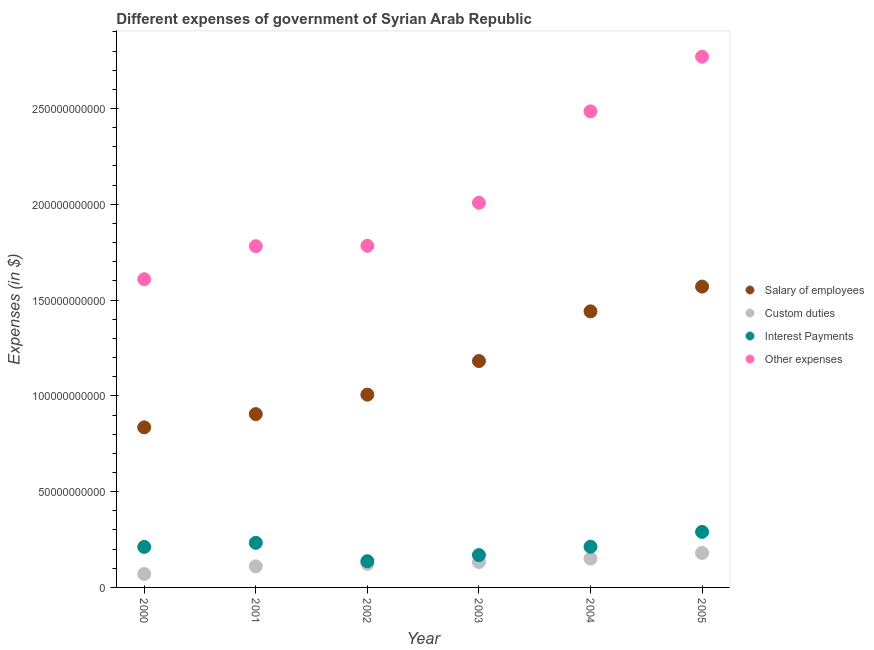Is the number of dotlines equal to the number of legend labels?
Ensure brevity in your answer.  Yes. What is the amount spent on salary of employees in 2004?
Give a very brief answer. 1.44e+11. Across all years, what is the maximum amount spent on custom duties?
Your response must be concise. 1.80e+1. Across all years, what is the minimum amount spent on other expenses?
Provide a short and direct response. 1.61e+11. What is the total amount spent on other expenses in the graph?
Ensure brevity in your answer.  1.24e+12. What is the difference between the amount spent on interest payments in 2001 and that in 2002?
Provide a short and direct response. 9.58e+09. What is the difference between the amount spent on interest payments in 2003 and the amount spent on salary of employees in 2000?
Make the answer very short. -6.67e+1. What is the average amount spent on other expenses per year?
Your response must be concise. 2.07e+11. In the year 2004, what is the difference between the amount spent on interest payments and amount spent on other expenses?
Provide a short and direct response. -2.27e+11. What is the ratio of the amount spent on custom duties in 2003 to that in 2004?
Provide a succinct answer. 0.88. What is the difference between the highest and the second highest amount spent on interest payments?
Your answer should be very brief. 5.72e+09. What is the difference between the highest and the lowest amount spent on other expenses?
Your response must be concise. 1.16e+11. In how many years, is the amount spent on interest payments greater than the average amount spent on interest payments taken over all years?
Offer a terse response. 4. Is the sum of the amount spent on other expenses in 2003 and 2005 greater than the maximum amount spent on salary of employees across all years?
Your answer should be very brief. Yes. Is it the case that in every year, the sum of the amount spent on custom duties and amount spent on other expenses is greater than the sum of amount spent on salary of employees and amount spent on interest payments?
Provide a short and direct response. Yes. Is it the case that in every year, the sum of the amount spent on salary of employees and amount spent on custom duties is greater than the amount spent on interest payments?
Your answer should be very brief. Yes. Does the amount spent on custom duties monotonically increase over the years?
Offer a very short reply. Yes. What is the difference between two consecutive major ticks on the Y-axis?
Keep it short and to the point. 5.00e+1. Are the values on the major ticks of Y-axis written in scientific E-notation?
Ensure brevity in your answer.  No. Does the graph contain any zero values?
Give a very brief answer. No. Where does the legend appear in the graph?
Make the answer very short. Center right. How many legend labels are there?
Your answer should be very brief. 4. How are the legend labels stacked?
Ensure brevity in your answer.  Vertical. What is the title of the graph?
Offer a terse response. Different expenses of government of Syrian Arab Republic. What is the label or title of the Y-axis?
Make the answer very short. Expenses (in $). What is the Expenses (in $) in Salary of employees in 2000?
Ensure brevity in your answer.  8.36e+1. What is the Expenses (in $) of Custom duties in 2000?
Keep it short and to the point. 7.03e+09. What is the Expenses (in $) in Interest Payments in 2000?
Provide a succinct answer. 2.11e+1. What is the Expenses (in $) in Other expenses in 2000?
Offer a terse response. 1.61e+11. What is the Expenses (in $) of Salary of employees in 2001?
Offer a very short reply. 9.05e+1. What is the Expenses (in $) of Custom duties in 2001?
Provide a succinct answer. 1.10e+1. What is the Expenses (in $) of Interest Payments in 2001?
Keep it short and to the point. 2.33e+1. What is the Expenses (in $) in Other expenses in 2001?
Offer a very short reply. 1.78e+11. What is the Expenses (in $) in Salary of employees in 2002?
Give a very brief answer. 1.01e+11. What is the Expenses (in $) of Custom duties in 2002?
Ensure brevity in your answer.  1.23e+1. What is the Expenses (in $) of Interest Payments in 2002?
Offer a very short reply. 1.37e+1. What is the Expenses (in $) of Other expenses in 2002?
Provide a succinct answer. 1.78e+11. What is the Expenses (in $) of Salary of employees in 2003?
Give a very brief answer. 1.18e+11. What is the Expenses (in $) of Custom duties in 2003?
Give a very brief answer. 1.32e+1. What is the Expenses (in $) in Interest Payments in 2003?
Give a very brief answer. 1.69e+1. What is the Expenses (in $) in Other expenses in 2003?
Your answer should be compact. 2.01e+11. What is the Expenses (in $) of Salary of employees in 2004?
Your answer should be compact. 1.44e+11. What is the Expenses (in $) of Custom duties in 2004?
Keep it short and to the point. 1.51e+1. What is the Expenses (in $) of Interest Payments in 2004?
Your response must be concise. 2.12e+1. What is the Expenses (in $) in Other expenses in 2004?
Keep it short and to the point. 2.48e+11. What is the Expenses (in $) in Salary of employees in 2005?
Give a very brief answer. 1.57e+11. What is the Expenses (in $) in Custom duties in 2005?
Your answer should be very brief. 1.80e+1. What is the Expenses (in $) in Interest Payments in 2005?
Your answer should be compact. 2.90e+1. What is the Expenses (in $) in Other expenses in 2005?
Keep it short and to the point. 2.77e+11. Across all years, what is the maximum Expenses (in $) of Salary of employees?
Provide a short and direct response. 1.57e+11. Across all years, what is the maximum Expenses (in $) in Custom duties?
Offer a terse response. 1.80e+1. Across all years, what is the maximum Expenses (in $) of Interest Payments?
Your answer should be compact. 2.90e+1. Across all years, what is the maximum Expenses (in $) of Other expenses?
Offer a very short reply. 2.77e+11. Across all years, what is the minimum Expenses (in $) of Salary of employees?
Ensure brevity in your answer.  8.36e+1. Across all years, what is the minimum Expenses (in $) in Custom duties?
Give a very brief answer. 7.03e+09. Across all years, what is the minimum Expenses (in $) of Interest Payments?
Offer a very short reply. 1.37e+1. Across all years, what is the minimum Expenses (in $) in Other expenses?
Give a very brief answer. 1.61e+11. What is the total Expenses (in $) of Salary of employees in the graph?
Ensure brevity in your answer.  6.94e+11. What is the total Expenses (in $) of Custom duties in the graph?
Offer a terse response. 7.66e+1. What is the total Expenses (in $) in Interest Payments in the graph?
Your answer should be compact. 1.25e+11. What is the total Expenses (in $) in Other expenses in the graph?
Offer a terse response. 1.24e+12. What is the difference between the Expenses (in $) of Salary of employees in 2000 and that in 2001?
Provide a succinct answer. -6.92e+09. What is the difference between the Expenses (in $) of Custom duties in 2000 and that in 2001?
Offer a very short reply. -3.97e+09. What is the difference between the Expenses (in $) in Interest Payments in 2000 and that in 2001?
Ensure brevity in your answer.  -2.14e+09. What is the difference between the Expenses (in $) in Other expenses in 2000 and that in 2001?
Your answer should be very brief. -1.72e+1. What is the difference between the Expenses (in $) in Salary of employees in 2000 and that in 2002?
Your response must be concise. -1.71e+1. What is the difference between the Expenses (in $) of Custom duties in 2000 and that in 2002?
Provide a short and direct response. -5.29e+09. What is the difference between the Expenses (in $) of Interest Payments in 2000 and that in 2002?
Ensure brevity in your answer.  7.45e+09. What is the difference between the Expenses (in $) in Other expenses in 2000 and that in 2002?
Provide a short and direct response. -1.74e+1. What is the difference between the Expenses (in $) of Salary of employees in 2000 and that in 2003?
Make the answer very short. -3.46e+1. What is the difference between the Expenses (in $) in Custom duties in 2000 and that in 2003?
Your answer should be compact. -6.22e+09. What is the difference between the Expenses (in $) of Interest Payments in 2000 and that in 2003?
Keep it short and to the point. 4.27e+09. What is the difference between the Expenses (in $) of Other expenses in 2000 and that in 2003?
Keep it short and to the point. -3.99e+1. What is the difference between the Expenses (in $) in Salary of employees in 2000 and that in 2004?
Your answer should be compact. -6.06e+1. What is the difference between the Expenses (in $) of Custom duties in 2000 and that in 2004?
Your answer should be very brief. -8.04e+09. What is the difference between the Expenses (in $) of Interest Payments in 2000 and that in 2004?
Ensure brevity in your answer.  -1.04e+08. What is the difference between the Expenses (in $) of Other expenses in 2000 and that in 2004?
Provide a succinct answer. -8.76e+1. What is the difference between the Expenses (in $) of Salary of employees in 2000 and that in 2005?
Your answer should be compact. -7.35e+1. What is the difference between the Expenses (in $) of Custom duties in 2000 and that in 2005?
Provide a short and direct response. -1.10e+1. What is the difference between the Expenses (in $) in Interest Payments in 2000 and that in 2005?
Your answer should be compact. -7.85e+09. What is the difference between the Expenses (in $) of Other expenses in 2000 and that in 2005?
Make the answer very short. -1.16e+11. What is the difference between the Expenses (in $) of Salary of employees in 2001 and that in 2002?
Your response must be concise. -1.02e+1. What is the difference between the Expenses (in $) in Custom duties in 2001 and that in 2002?
Your answer should be very brief. -1.32e+09. What is the difference between the Expenses (in $) in Interest Payments in 2001 and that in 2002?
Give a very brief answer. 9.58e+09. What is the difference between the Expenses (in $) of Other expenses in 2001 and that in 2002?
Keep it short and to the point. -2.10e+08. What is the difference between the Expenses (in $) of Salary of employees in 2001 and that in 2003?
Your answer should be very brief. -2.77e+1. What is the difference between the Expenses (in $) of Custom duties in 2001 and that in 2003?
Offer a very short reply. -2.25e+09. What is the difference between the Expenses (in $) of Interest Payments in 2001 and that in 2003?
Provide a succinct answer. 6.40e+09. What is the difference between the Expenses (in $) of Other expenses in 2001 and that in 2003?
Give a very brief answer. -2.27e+1. What is the difference between the Expenses (in $) in Salary of employees in 2001 and that in 2004?
Make the answer very short. -5.36e+1. What is the difference between the Expenses (in $) in Custom duties in 2001 and that in 2004?
Make the answer very short. -4.06e+09. What is the difference between the Expenses (in $) in Interest Payments in 2001 and that in 2004?
Give a very brief answer. 2.03e+09. What is the difference between the Expenses (in $) in Other expenses in 2001 and that in 2004?
Your answer should be compact. -7.04e+1. What is the difference between the Expenses (in $) of Salary of employees in 2001 and that in 2005?
Keep it short and to the point. -6.66e+1. What is the difference between the Expenses (in $) of Custom duties in 2001 and that in 2005?
Ensure brevity in your answer.  -7.00e+09. What is the difference between the Expenses (in $) of Interest Payments in 2001 and that in 2005?
Your answer should be very brief. -5.72e+09. What is the difference between the Expenses (in $) of Other expenses in 2001 and that in 2005?
Your answer should be very brief. -9.89e+1. What is the difference between the Expenses (in $) in Salary of employees in 2002 and that in 2003?
Your answer should be compact. -1.75e+1. What is the difference between the Expenses (in $) of Custom duties in 2002 and that in 2003?
Keep it short and to the point. -9.30e+08. What is the difference between the Expenses (in $) in Interest Payments in 2002 and that in 2003?
Keep it short and to the point. -3.18e+09. What is the difference between the Expenses (in $) of Other expenses in 2002 and that in 2003?
Provide a short and direct response. -2.24e+1. What is the difference between the Expenses (in $) of Salary of employees in 2002 and that in 2004?
Provide a short and direct response. -4.35e+1. What is the difference between the Expenses (in $) of Custom duties in 2002 and that in 2004?
Make the answer very short. -2.75e+09. What is the difference between the Expenses (in $) in Interest Payments in 2002 and that in 2004?
Ensure brevity in your answer.  -7.55e+09. What is the difference between the Expenses (in $) of Other expenses in 2002 and that in 2004?
Provide a succinct answer. -7.02e+1. What is the difference between the Expenses (in $) of Salary of employees in 2002 and that in 2005?
Provide a succinct answer. -5.64e+1. What is the difference between the Expenses (in $) in Custom duties in 2002 and that in 2005?
Offer a very short reply. -5.68e+09. What is the difference between the Expenses (in $) of Interest Payments in 2002 and that in 2005?
Your answer should be very brief. -1.53e+1. What is the difference between the Expenses (in $) of Other expenses in 2002 and that in 2005?
Ensure brevity in your answer.  -9.87e+1. What is the difference between the Expenses (in $) in Salary of employees in 2003 and that in 2004?
Your response must be concise. -2.60e+1. What is the difference between the Expenses (in $) of Custom duties in 2003 and that in 2004?
Your answer should be compact. -1.82e+09. What is the difference between the Expenses (in $) in Interest Payments in 2003 and that in 2004?
Provide a short and direct response. -4.37e+09. What is the difference between the Expenses (in $) of Other expenses in 2003 and that in 2004?
Offer a very short reply. -4.77e+1. What is the difference between the Expenses (in $) of Salary of employees in 2003 and that in 2005?
Give a very brief answer. -3.89e+1. What is the difference between the Expenses (in $) in Custom duties in 2003 and that in 2005?
Give a very brief answer. -4.75e+09. What is the difference between the Expenses (in $) in Interest Payments in 2003 and that in 2005?
Ensure brevity in your answer.  -1.21e+1. What is the difference between the Expenses (in $) of Other expenses in 2003 and that in 2005?
Keep it short and to the point. -7.63e+1. What is the difference between the Expenses (in $) in Salary of employees in 2004 and that in 2005?
Ensure brevity in your answer.  -1.29e+1. What is the difference between the Expenses (in $) of Custom duties in 2004 and that in 2005?
Ensure brevity in your answer.  -2.93e+09. What is the difference between the Expenses (in $) in Interest Payments in 2004 and that in 2005?
Provide a short and direct response. -7.75e+09. What is the difference between the Expenses (in $) of Other expenses in 2004 and that in 2005?
Ensure brevity in your answer.  -2.85e+1. What is the difference between the Expenses (in $) in Salary of employees in 2000 and the Expenses (in $) in Custom duties in 2001?
Make the answer very short. 7.26e+1. What is the difference between the Expenses (in $) of Salary of employees in 2000 and the Expenses (in $) of Interest Payments in 2001?
Ensure brevity in your answer.  6.03e+1. What is the difference between the Expenses (in $) of Salary of employees in 2000 and the Expenses (in $) of Other expenses in 2001?
Ensure brevity in your answer.  -9.46e+1. What is the difference between the Expenses (in $) of Custom duties in 2000 and the Expenses (in $) of Interest Payments in 2001?
Your answer should be very brief. -1.63e+1. What is the difference between the Expenses (in $) in Custom duties in 2000 and the Expenses (in $) in Other expenses in 2001?
Ensure brevity in your answer.  -1.71e+11. What is the difference between the Expenses (in $) in Interest Payments in 2000 and the Expenses (in $) in Other expenses in 2001?
Give a very brief answer. -1.57e+11. What is the difference between the Expenses (in $) in Salary of employees in 2000 and the Expenses (in $) in Custom duties in 2002?
Provide a succinct answer. 7.12e+1. What is the difference between the Expenses (in $) of Salary of employees in 2000 and the Expenses (in $) of Interest Payments in 2002?
Your response must be concise. 6.99e+1. What is the difference between the Expenses (in $) in Salary of employees in 2000 and the Expenses (in $) in Other expenses in 2002?
Make the answer very short. -9.48e+1. What is the difference between the Expenses (in $) in Custom duties in 2000 and the Expenses (in $) in Interest Payments in 2002?
Keep it short and to the point. -6.67e+09. What is the difference between the Expenses (in $) of Custom duties in 2000 and the Expenses (in $) of Other expenses in 2002?
Provide a short and direct response. -1.71e+11. What is the difference between the Expenses (in $) in Interest Payments in 2000 and the Expenses (in $) in Other expenses in 2002?
Your response must be concise. -1.57e+11. What is the difference between the Expenses (in $) of Salary of employees in 2000 and the Expenses (in $) of Custom duties in 2003?
Give a very brief answer. 7.03e+1. What is the difference between the Expenses (in $) of Salary of employees in 2000 and the Expenses (in $) of Interest Payments in 2003?
Make the answer very short. 6.67e+1. What is the difference between the Expenses (in $) in Salary of employees in 2000 and the Expenses (in $) in Other expenses in 2003?
Your answer should be compact. -1.17e+11. What is the difference between the Expenses (in $) of Custom duties in 2000 and the Expenses (in $) of Interest Payments in 2003?
Your response must be concise. -9.85e+09. What is the difference between the Expenses (in $) of Custom duties in 2000 and the Expenses (in $) of Other expenses in 2003?
Offer a terse response. -1.94e+11. What is the difference between the Expenses (in $) of Interest Payments in 2000 and the Expenses (in $) of Other expenses in 2003?
Your answer should be compact. -1.80e+11. What is the difference between the Expenses (in $) of Salary of employees in 2000 and the Expenses (in $) of Custom duties in 2004?
Make the answer very short. 6.85e+1. What is the difference between the Expenses (in $) of Salary of employees in 2000 and the Expenses (in $) of Interest Payments in 2004?
Make the answer very short. 6.23e+1. What is the difference between the Expenses (in $) in Salary of employees in 2000 and the Expenses (in $) in Other expenses in 2004?
Provide a short and direct response. -1.65e+11. What is the difference between the Expenses (in $) in Custom duties in 2000 and the Expenses (in $) in Interest Payments in 2004?
Your response must be concise. -1.42e+1. What is the difference between the Expenses (in $) of Custom duties in 2000 and the Expenses (in $) of Other expenses in 2004?
Offer a terse response. -2.41e+11. What is the difference between the Expenses (in $) of Interest Payments in 2000 and the Expenses (in $) of Other expenses in 2004?
Keep it short and to the point. -2.27e+11. What is the difference between the Expenses (in $) of Salary of employees in 2000 and the Expenses (in $) of Custom duties in 2005?
Make the answer very short. 6.56e+1. What is the difference between the Expenses (in $) in Salary of employees in 2000 and the Expenses (in $) in Interest Payments in 2005?
Ensure brevity in your answer.  5.46e+1. What is the difference between the Expenses (in $) in Salary of employees in 2000 and the Expenses (in $) in Other expenses in 2005?
Offer a terse response. -1.93e+11. What is the difference between the Expenses (in $) of Custom duties in 2000 and the Expenses (in $) of Interest Payments in 2005?
Give a very brief answer. -2.20e+1. What is the difference between the Expenses (in $) in Custom duties in 2000 and the Expenses (in $) in Other expenses in 2005?
Your answer should be very brief. -2.70e+11. What is the difference between the Expenses (in $) in Interest Payments in 2000 and the Expenses (in $) in Other expenses in 2005?
Provide a succinct answer. -2.56e+11. What is the difference between the Expenses (in $) of Salary of employees in 2001 and the Expenses (in $) of Custom duties in 2002?
Offer a terse response. 7.82e+1. What is the difference between the Expenses (in $) of Salary of employees in 2001 and the Expenses (in $) of Interest Payments in 2002?
Make the answer very short. 7.68e+1. What is the difference between the Expenses (in $) in Salary of employees in 2001 and the Expenses (in $) in Other expenses in 2002?
Ensure brevity in your answer.  -8.79e+1. What is the difference between the Expenses (in $) of Custom duties in 2001 and the Expenses (in $) of Interest Payments in 2002?
Offer a very short reply. -2.70e+09. What is the difference between the Expenses (in $) in Custom duties in 2001 and the Expenses (in $) in Other expenses in 2002?
Your answer should be very brief. -1.67e+11. What is the difference between the Expenses (in $) in Interest Payments in 2001 and the Expenses (in $) in Other expenses in 2002?
Provide a short and direct response. -1.55e+11. What is the difference between the Expenses (in $) in Salary of employees in 2001 and the Expenses (in $) in Custom duties in 2003?
Provide a short and direct response. 7.72e+1. What is the difference between the Expenses (in $) in Salary of employees in 2001 and the Expenses (in $) in Interest Payments in 2003?
Give a very brief answer. 7.36e+1. What is the difference between the Expenses (in $) of Salary of employees in 2001 and the Expenses (in $) of Other expenses in 2003?
Your response must be concise. -1.10e+11. What is the difference between the Expenses (in $) in Custom duties in 2001 and the Expenses (in $) in Interest Payments in 2003?
Your response must be concise. -5.88e+09. What is the difference between the Expenses (in $) of Custom duties in 2001 and the Expenses (in $) of Other expenses in 2003?
Your answer should be compact. -1.90e+11. What is the difference between the Expenses (in $) in Interest Payments in 2001 and the Expenses (in $) in Other expenses in 2003?
Provide a short and direct response. -1.77e+11. What is the difference between the Expenses (in $) of Salary of employees in 2001 and the Expenses (in $) of Custom duties in 2004?
Keep it short and to the point. 7.54e+1. What is the difference between the Expenses (in $) in Salary of employees in 2001 and the Expenses (in $) in Interest Payments in 2004?
Keep it short and to the point. 6.92e+1. What is the difference between the Expenses (in $) in Salary of employees in 2001 and the Expenses (in $) in Other expenses in 2004?
Offer a very short reply. -1.58e+11. What is the difference between the Expenses (in $) in Custom duties in 2001 and the Expenses (in $) in Interest Payments in 2004?
Make the answer very short. -1.03e+1. What is the difference between the Expenses (in $) of Custom duties in 2001 and the Expenses (in $) of Other expenses in 2004?
Ensure brevity in your answer.  -2.37e+11. What is the difference between the Expenses (in $) in Interest Payments in 2001 and the Expenses (in $) in Other expenses in 2004?
Keep it short and to the point. -2.25e+11. What is the difference between the Expenses (in $) in Salary of employees in 2001 and the Expenses (in $) in Custom duties in 2005?
Make the answer very short. 7.25e+1. What is the difference between the Expenses (in $) of Salary of employees in 2001 and the Expenses (in $) of Interest Payments in 2005?
Ensure brevity in your answer.  6.15e+1. What is the difference between the Expenses (in $) of Salary of employees in 2001 and the Expenses (in $) of Other expenses in 2005?
Your response must be concise. -1.87e+11. What is the difference between the Expenses (in $) in Custom duties in 2001 and the Expenses (in $) in Interest Payments in 2005?
Your response must be concise. -1.80e+1. What is the difference between the Expenses (in $) of Custom duties in 2001 and the Expenses (in $) of Other expenses in 2005?
Ensure brevity in your answer.  -2.66e+11. What is the difference between the Expenses (in $) of Interest Payments in 2001 and the Expenses (in $) of Other expenses in 2005?
Provide a succinct answer. -2.54e+11. What is the difference between the Expenses (in $) of Salary of employees in 2002 and the Expenses (in $) of Custom duties in 2003?
Your answer should be very brief. 8.74e+1. What is the difference between the Expenses (in $) of Salary of employees in 2002 and the Expenses (in $) of Interest Payments in 2003?
Offer a terse response. 8.38e+1. What is the difference between the Expenses (in $) of Salary of employees in 2002 and the Expenses (in $) of Other expenses in 2003?
Your response must be concise. -1.00e+11. What is the difference between the Expenses (in $) in Custom duties in 2002 and the Expenses (in $) in Interest Payments in 2003?
Keep it short and to the point. -4.56e+09. What is the difference between the Expenses (in $) of Custom duties in 2002 and the Expenses (in $) of Other expenses in 2003?
Make the answer very short. -1.88e+11. What is the difference between the Expenses (in $) of Interest Payments in 2002 and the Expenses (in $) of Other expenses in 2003?
Make the answer very short. -1.87e+11. What is the difference between the Expenses (in $) of Salary of employees in 2002 and the Expenses (in $) of Custom duties in 2004?
Ensure brevity in your answer.  8.56e+1. What is the difference between the Expenses (in $) in Salary of employees in 2002 and the Expenses (in $) in Interest Payments in 2004?
Your answer should be very brief. 7.94e+1. What is the difference between the Expenses (in $) of Salary of employees in 2002 and the Expenses (in $) of Other expenses in 2004?
Your answer should be compact. -1.48e+11. What is the difference between the Expenses (in $) of Custom duties in 2002 and the Expenses (in $) of Interest Payments in 2004?
Offer a terse response. -8.93e+09. What is the difference between the Expenses (in $) of Custom duties in 2002 and the Expenses (in $) of Other expenses in 2004?
Your answer should be compact. -2.36e+11. What is the difference between the Expenses (in $) in Interest Payments in 2002 and the Expenses (in $) in Other expenses in 2004?
Keep it short and to the point. -2.35e+11. What is the difference between the Expenses (in $) of Salary of employees in 2002 and the Expenses (in $) of Custom duties in 2005?
Provide a succinct answer. 8.26e+1. What is the difference between the Expenses (in $) of Salary of employees in 2002 and the Expenses (in $) of Interest Payments in 2005?
Your response must be concise. 7.16e+1. What is the difference between the Expenses (in $) of Salary of employees in 2002 and the Expenses (in $) of Other expenses in 2005?
Provide a succinct answer. -1.76e+11. What is the difference between the Expenses (in $) in Custom duties in 2002 and the Expenses (in $) in Interest Payments in 2005?
Your answer should be very brief. -1.67e+1. What is the difference between the Expenses (in $) of Custom duties in 2002 and the Expenses (in $) of Other expenses in 2005?
Your answer should be very brief. -2.65e+11. What is the difference between the Expenses (in $) of Interest Payments in 2002 and the Expenses (in $) of Other expenses in 2005?
Offer a terse response. -2.63e+11. What is the difference between the Expenses (in $) of Salary of employees in 2003 and the Expenses (in $) of Custom duties in 2004?
Keep it short and to the point. 1.03e+11. What is the difference between the Expenses (in $) of Salary of employees in 2003 and the Expenses (in $) of Interest Payments in 2004?
Provide a short and direct response. 9.69e+1. What is the difference between the Expenses (in $) in Salary of employees in 2003 and the Expenses (in $) in Other expenses in 2004?
Give a very brief answer. -1.30e+11. What is the difference between the Expenses (in $) of Custom duties in 2003 and the Expenses (in $) of Interest Payments in 2004?
Ensure brevity in your answer.  -8.00e+09. What is the difference between the Expenses (in $) in Custom duties in 2003 and the Expenses (in $) in Other expenses in 2004?
Ensure brevity in your answer.  -2.35e+11. What is the difference between the Expenses (in $) in Interest Payments in 2003 and the Expenses (in $) in Other expenses in 2004?
Keep it short and to the point. -2.32e+11. What is the difference between the Expenses (in $) in Salary of employees in 2003 and the Expenses (in $) in Custom duties in 2005?
Your answer should be compact. 1.00e+11. What is the difference between the Expenses (in $) in Salary of employees in 2003 and the Expenses (in $) in Interest Payments in 2005?
Your response must be concise. 8.92e+1. What is the difference between the Expenses (in $) of Salary of employees in 2003 and the Expenses (in $) of Other expenses in 2005?
Offer a very short reply. -1.59e+11. What is the difference between the Expenses (in $) of Custom duties in 2003 and the Expenses (in $) of Interest Payments in 2005?
Make the answer very short. -1.58e+1. What is the difference between the Expenses (in $) of Custom duties in 2003 and the Expenses (in $) of Other expenses in 2005?
Make the answer very short. -2.64e+11. What is the difference between the Expenses (in $) in Interest Payments in 2003 and the Expenses (in $) in Other expenses in 2005?
Your response must be concise. -2.60e+11. What is the difference between the Expenses (in $) of Salary of employees in 2004 and the Expenses (in $) of Custom duties in 2005?
Make the answer very short. 1.26e+11. What is the difference between the Expenses (in $) in Salary of employees in 2004 and the Expenses (in $) in Interest Payments in 2005?
Make the answer very short. 1.15e+11. What is the difference between the Expenses (in $) of Salary of employees in 2004 and the Expenses (in $) of Other expenses in 2005?
Offer a very short reply. -1.33e+11. What is the difference between the Expenses (in $) in Custom duties in 2004 and the Expenses (in $) in Interest Payments in 2005?
Ensure brevity in your answer.  -1.39e+1. What is the difference between the Expenses (in $) of Custom duties in 2004 and the Expenses (in $) of Other expenses in 2005?
Your answer should be compact. -2.62e+11. What is the difference between the Expenses (in $) in Interest Payments in 2004 and the Expenses (in $) in Other expenses in 2005?
Keep it short and to the point. -2.56e+11. What is the average Expenses (in $) in Salary of employees per year?
Give a very brief answer. 1.16e+11. What is the average Expenses (in $) in Custom duties per year?
Provide a short and direct response. 1.28e+1. What is the average Expenses (in $) in Interest Payments per year?
Your response must be concise. 2.09e+1. What is the average Expenses (in $) of Other expenses per year?
Ensure brevity in your answer.  2.07e+11. In the year 2000, what is the difference between the Expenses (in $) of Salary of employees and Expenses (in $) of Custom duties?
Your answer should be compact. 7.65e+1. In the year 2000, what is the difference between the Expenses (in $) in Salary of employees and Expenses (in $) in Interest Payments?
Provide a succinct answer. 6.24e+1. In the year 2000, what is the difference between the Expenses (in $) of Salary of employees and Expenses (in $) of Other expenses?
Your answer should be compact. -7.73e+1. In the year 2000, what is the difference between the Expenses (in $) of Custom duties and Expenses (in $) of Interest Payments?
Your answer should be very brief. -1.41e+1. In the year 2000, what is the difference between the Expenses (in $) in Custom duties and Expenses (in $) in Other expenses?
Offer a terse response. -1.54e+11. In the year 2000, what is the difference between the Expenses (in $) of Interest Payments and Expenses (in $) of Other expenses?
Give a very brief answer. -1.40e+11. In the year 2001, what is the difference between the Expenses (in $) of Salary of employees and Expenses (in $) of Custom duties?
Provide a succinct answer. 7.95e+1. In the year 2001, what is the difference between the Expenses (in $) in Salary of employees and Expenses (in $) in Interest Payments?
Keep it short and to the point. 6.72e+1. In the year 2001, what is the difference between the Expenses (in $) of Salary of employees and Expenses (in $) of Other expenses?
Make the answer very short. -8.76e+1. In the year 2001, what is the difference between the Expenses (in $) of Custom duties and Expenses (in $) of Interest Payments?
Your answer should be compact. -1.23e+1. In the year 2001, what is the difference between the Expenses (in $) of Custom duties and Expenses (in $) of Other expenses?
Keep it short and to the point. -1.67e+11. In the year 2001, what is the difference between the Expenses (in $) of Interest Payments and Expenses (in $) of Other expenses?
Offer a very short reply. -1.55e+11. In the year 2002, what is the difference between the Expenses (in $) of Salary of employees and Expenses (in $) of Custom duties?
Keep it short and to the point. 8.83e+1. In the year 2002, what is the difference between the Expenses (in $) of Salary of employees and Expenses (in $) of Interest Payments?
Provide a short and direct response. 8.69e+1. In the year 2002, what is the difference between the Expenses (in $) of Salary of employees and Expenses (in $) of Other expenses?
Your answer should be compact. -7.77e+1. In the year 2002, what is the difference between the Expenses (in $) of Custom duties and Expenses (in $) of Interest Payments?
Your answer should be compact. -1.38e+09. In the year 2002, what is the difference between the Expenses (in $) of Custom duties and Expenses (in $) of Other expenses?
Keep it short and to the point. -1.66e+11. In the year 2002, what is the difference between the Expenses (in $) of Interest Payments and Expenses (in $) of Other expenses?
Ensure brevity in your answer.  -1.65e+11. In the year 2003, what is the difference between the Expenses (in $) of Salary of employees and Expenses (in $) of Custom duties?
Make the answer very short. 1.05e+11. In the year 2003, what is the difference between the Expenses (in $) of Salary of employees and Expenses (in $) of Interest Payments?
Offer a terse response. 1.01e+11. In the year 2003, what is the difference between the Expenses (in $) in Salary of employees and Expenses (in $) in Other expenses?
Give a very brief answer. -8.26e+1. In the year 2003, what is the difference between the Expenses (in $) in Custom duties and Expenses (in $) in Interest Payments?
Provide a short and direct response. -3.63e+09. In the year 2003, what is the difference between the Expenses (in $) in Custom duties and Expenses (in $) in Other expenses?
Provide a succinct answer. -1.88e+11. In the year 2003, what is the difference between the Expenses (in $) of Interest Payments and Expenses (in $) of Other expenses?
Make the answer very short. -1.84e+11. In the year 2004, what is the difference between the Expenses (in $) in Salary of employees and Expenses (in $) in Custom duties?
Make the answer very short. 1.29e+11. In the year 2004, what is the difference between the Expenses (in $) in Salary of employees and Expenses (in $) in Interest Payments?
Offer a very short reply. 1.23e+11. In the year 2004, what is the difference between the Expenses (in $) in Salary of employees and Expenses (in $) in Other expenses?
Offer a very short reply. -1.04e+11. In the year 2004, what is the difference between the Expenses (in $) in Custom duties and Expenses (in $) in Interest Payments?
Keep it short and to the point. -6.19e+09. In the year 2004, what is the difference between the Expenses (in $) in Custom duties and Expenses (in $) in Other expenses?
Your answer should be compact. -2.33e+11. In the year 2004, what is the difference between the Expenses (in $) in Interest Payments and Expenses (in $) in Other expenses?
Offer a terse response. -2.27e+11. In the year 2005, what is the difference between the Expenses (in $) of Salary of employees and Expenses (in $) of Custom duties?
Your answer should be very brief. 1.39e+11. In the year 2005, what is the difference between the Expenses (in $) in Salary of employees and Expenses (in $) in Interest Payments?
Make the answer very short. 1.28e+11. In the year 2005, what is the difference between the Expenses (in $) of Salary of employees and Expenses (in $) of Other expenses?
Ensure brevity in your answer.  -1.20e+11. In the year 2005, what is the difference between the Expenses (in $) in Custom duties and Expenses (in $) in Interest Payments?
Keep it short and to the point. -1.10e+1. In the year 2005, what is the difference between the Expenses (in $) of Custom duties and Expenses (in $) of Other expenses?
Give a very brief answer. -2.59e+11. In the year 2005, what is the difference between the Expenses (in $) of Interest Payments and Expenses (in $) of Other expenses?
Ensure brevity in your answer.  -2.48e+11. What is the ratio of the Expenses (in $) in Salary of employees in 2000 to that in 2001?
Provide a succinct answer. 0.92. What is the ratio of the Expenses (in $) in Custom duties in 2000 to that in 2001?
Give a very brief answer. 0.64. What is the ratio of the Expenses (in $) of Interest Payments in 2000 to that in 2001?
Give a very brief answer. 0.91. What is the ratio of the Expenses (in $) in Other expenses in 2000 to that in 2001?
Provide a short and direct response. 0.9. What is the ratio of the Expenses (in $) of Salary of employees in 2000 to that in 2002?
Your answer should be very brief. 0.83. What is the ratio of the Expenses (in $) in Custom duties in 2000 to that in 2002?
Make the answer very short. 0.57. What is the ratio of the Expenses (in $) in Interest Payments in 2000 to that in 2002?
Your answer should be very brief. 1.54. What is the ratio of the Expenses (in $) in Other expenses in 2000 to that in 2002?
Ensure brevity in your answer.  0.9. What is the ratio of the Expenses (in $) of Salary of employees in 2000 to that in 2003?
Your response must be concise. 0.71. What is the ratio of the Expenses (in $) in Custom duties in 2000 to that in 2003?
Provide a succinct answer. 0.53. What is the ratio of the Expenses (in $) in Interest Payments in 2000 to that in 2003?
Provide a short and direct response. 1.25. What is the ratio of the Expenses (in $) of Other expenses in 2000 to that in 2003?
Provide a succinct answer. 0.8. What is the ratio of the Expenses (in $) of Salary of employees in 2000 to that in 2004?
Ensure brevity in your answer.  0.58. What is the ratio of the Expenses (in $) of Custom duties in 2000 to that in 2004?
Your response must be concise. 0.47. What is the ratio of the Expenses (in $) of Other expenses in 2000 to that in 2004?
Your response must be concise. 0.65. What is the ratio of the Expenses (in $) in Salary of employees in 2000 to that in 2005?
Offer a very short reply. 0.53. What is the ratio of the Expenses (in $) in Custom duties in 2000 to that in 2005?
Make the answer very short. 0.39. What is the ratio of the Expenses (in $) in Interest Payments in 2000 to that in 2005?
Your answer should be very brief. 0.73. What is the ratio of the Expenses (in $) of Other expenses in 2000 to that in 2005?
Keep it short and to the point. 0.58. What is the ratio of the Expenses (in $) of Salary of employees in 2001 to that in 2002?
Give a very brief answer. 0.9. What is the ratio of the Expenses (in $) in Custom duties in 2001 to that in 2002?
Offer a terse response. 0.89. What is the ratio of the Expenses (in $) in Interest Payments in 2001 to that in 2002?
Your response must be concise. 1.7. What is the ratio of the Expenses (in $) in Other expenses in 2001 to that in 2002?
Your answer should be very brief. 1. What is the ratio of the Expenses (in $) of Salary of employees in 2001 to that in 2003?
Ensure brevity in your answer.  0.77. What is the ratio of the Expenses (in $) of Custom duties in 2001 to that in 2003?
Ensure brevity in your answer.  0.83. What is the ratio of the Expenses (in $) in Interest Payments in 2001 to that in 2003?
Your response must be concise. 1.38. What is the ratio of the Expenses (in $) in Other expenses in 2001 to that in 2003?
Provide a short and direct response. 0.89. What is the ratio of the Expenses (in $) in Salary of employees in 2001 to that in 2004?
Give a very brief answer. 0.63. What is the ratio of the Expenses (in $) in Custom duties in 2001 to that in 2004?
Provide a succinct answer. 0.73. What is the ratio of the Expenses (in $) in Interest Payments in 2001 to that in 2004?
Your response must be concise. 1.1. What is the ratio of the Expenses (in $) of Other expenses in 2001 to that in 2004?
Keep it short and to the point. 0.72. What is the ratio of the Expenses (in $) of Salary of employees in 2001 to that in 2005?
Make the answer very short. 0.58. What is the ratio of the Expenses (in $) of Custom duties in 2001 to that in 2005?
Your answer should be very brief. 0.61. What is the ratio of the Expenses (in $) in Interest Payments in 2001 to that in 2005?
Offer a very short reply. 0.8. What is the ratio of the Expenses (in $) of Other expenses in 2001 to that in 2005?
Provide a short and direct response. 0.64. What is the ratio of the Expenses (in $) of Salary of employees in 2002 to that in 2003?
Offer a terse response. 0.85. What is the ratio of the Expenses (in $) of Custom duties in 2002 to that in 2003?
Offer a very short reply. 0.93. What is the ratio of the Expenses (in $) of Interest Payments in 2002 to that in 2003?
Give a very brief answer. 0.81. What is the ratio of the Expenses (in $) in Other expenses in 2002 to that in 2003?
Give a very brief answer. 0.89. What is the ratio of the Expenses (in $) of Salary of employees in 2002 to that in 2004?
Offer a terse response. 0.7. What is the ratio of the Expenses (in $) of Custom duties in 2002 to that in 2004?
Make the answer very short. 0.82. What is the ratio of the Expenses (in $) of Interest Payments in 2002 to that in 2004?
Give a very brief answer. 0.64. What is the ratio of the Expenses (in $) of Other expenses in 2002 to that in 2004?
Offer a terse response. 0.72. What is the ratio of the Expenses (in $) in Salary of employees in 2002 to that in 2005?
Keep it short and to the point. 0.64. What is the ratio of the Expenses (in $) in Custom duties in 2002 to that in 2005?
Keep it short and to the point. 0.68. What is the ratio of the Expenses (in $) in Interest Payments in 2002 to that in 2005?
Ensure brevity in your answer.  0.47. What is the ratio of the Expenses (in $) in Other expenses in 2002 to that in 2005?
Keep it short and to the point. 0.64. What is the ratio of the Expenses (in $) in Salary of employees in 2003 to that in 2004?
Your response must be concise. 0.82. What is the ratio of the Expenses (in $) in Custom duties in 2003 to that in 2004?
Provide a succinct answer. 0.88. What is the ratio of the Expenses (in $) of Interest Payments in 2003 to that in 2004?
Your answer should be compact. 0.79. What is the ratio of the Expenses (in $) of Other expenses in 2003 to that in 2004?
Your answer should be compact. 0.81. What is the ratio of the Expenses (in $) of Salary of employees in 2003 to that in 2005?
Your answer should be very brief. 0.75. What is the ratio of the Expenses (in $) of Custom duties in 2003 to that in 2005?
Ensure brevity in your answer.  0.74. What is the ratio of the Expenses (in $) in Interest Payments in 2003 to that in 2005?
Your answer should be very brief. 0.58. What is the ratio of the Expenses (in $) of Other expenses in 2003 to that in 2005?
Your answer should be very brief. 0.72. What is the ratio of the Expenses (in $) in Salary of employees in 2004 to that in 2005?
Keep it short and to the point. 0.92. What is the ratio of the Expenses (in $) of Custom duties in 2004 to that in 2005?
Offer a terse response. 0.84. What is the ratio of the Expenses (in $) in Interest Payments in 2004 to that in 2005?
Give a very brief answer. 0.73. What is the ratio of the Expenses (in $) in Other expenses in 2004 to that in 2005?
Your answer should be compact. 0.9. What is the difference between the highest and the second highest Expenses (in $) in Salary of employees?
Give a very brief answer. 1.29e+1. What is the difference between the highest and the second highest Expenses (in $) of Custom duties?
Provide a succinct answer. 2.93e+09. What is the difference between the highest and the second highest Expenses (in $) of Interest Payments?
Your answer should be very brief. 5.72e+09. What is the difference between the highest and the second highest Expenses (in $) in Other expenses?
Keep it short and to the point. 2.85e+1. What is the difference between the highest and the lowest Expenses (in $) of Salary of employees?
Provide a short and direct response. 7.35e+1. What is the difference between the highest and the lowest Expenses (in $) in Custom duties?
Make the answer very short. 1.10e+1. What is the difference between the highest and the lowest Expenses (in $) in Interest Payments?
Offer a terse response. 1.53e+1. What is the difference between the highest and the lowest Expenses (in $) of Other expenses?
Offer a very short reply. 1.16e+11. 